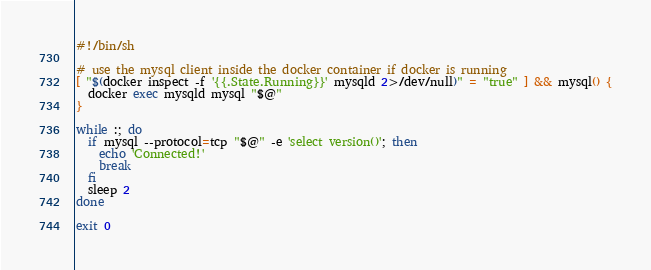Convert code to text. <code><loc_0><loc_0><loc_500><loc_500><_Bash_>#!/bin/sh

# use the mysql client inside the docker container if docker is running
[ "$(docker inspect -f '{{.State.Running}}' mysqld 2>/dev/null)" = "true" ] && mysql() {
  docker exec mysqld mysql "$@"
}

while :; do
  if mysql --protocol=tcp "$@" -e 'select version()'; then
    echo 'Connected!'
    break
  fi
  sleep 2
done

exit 0
</code> 